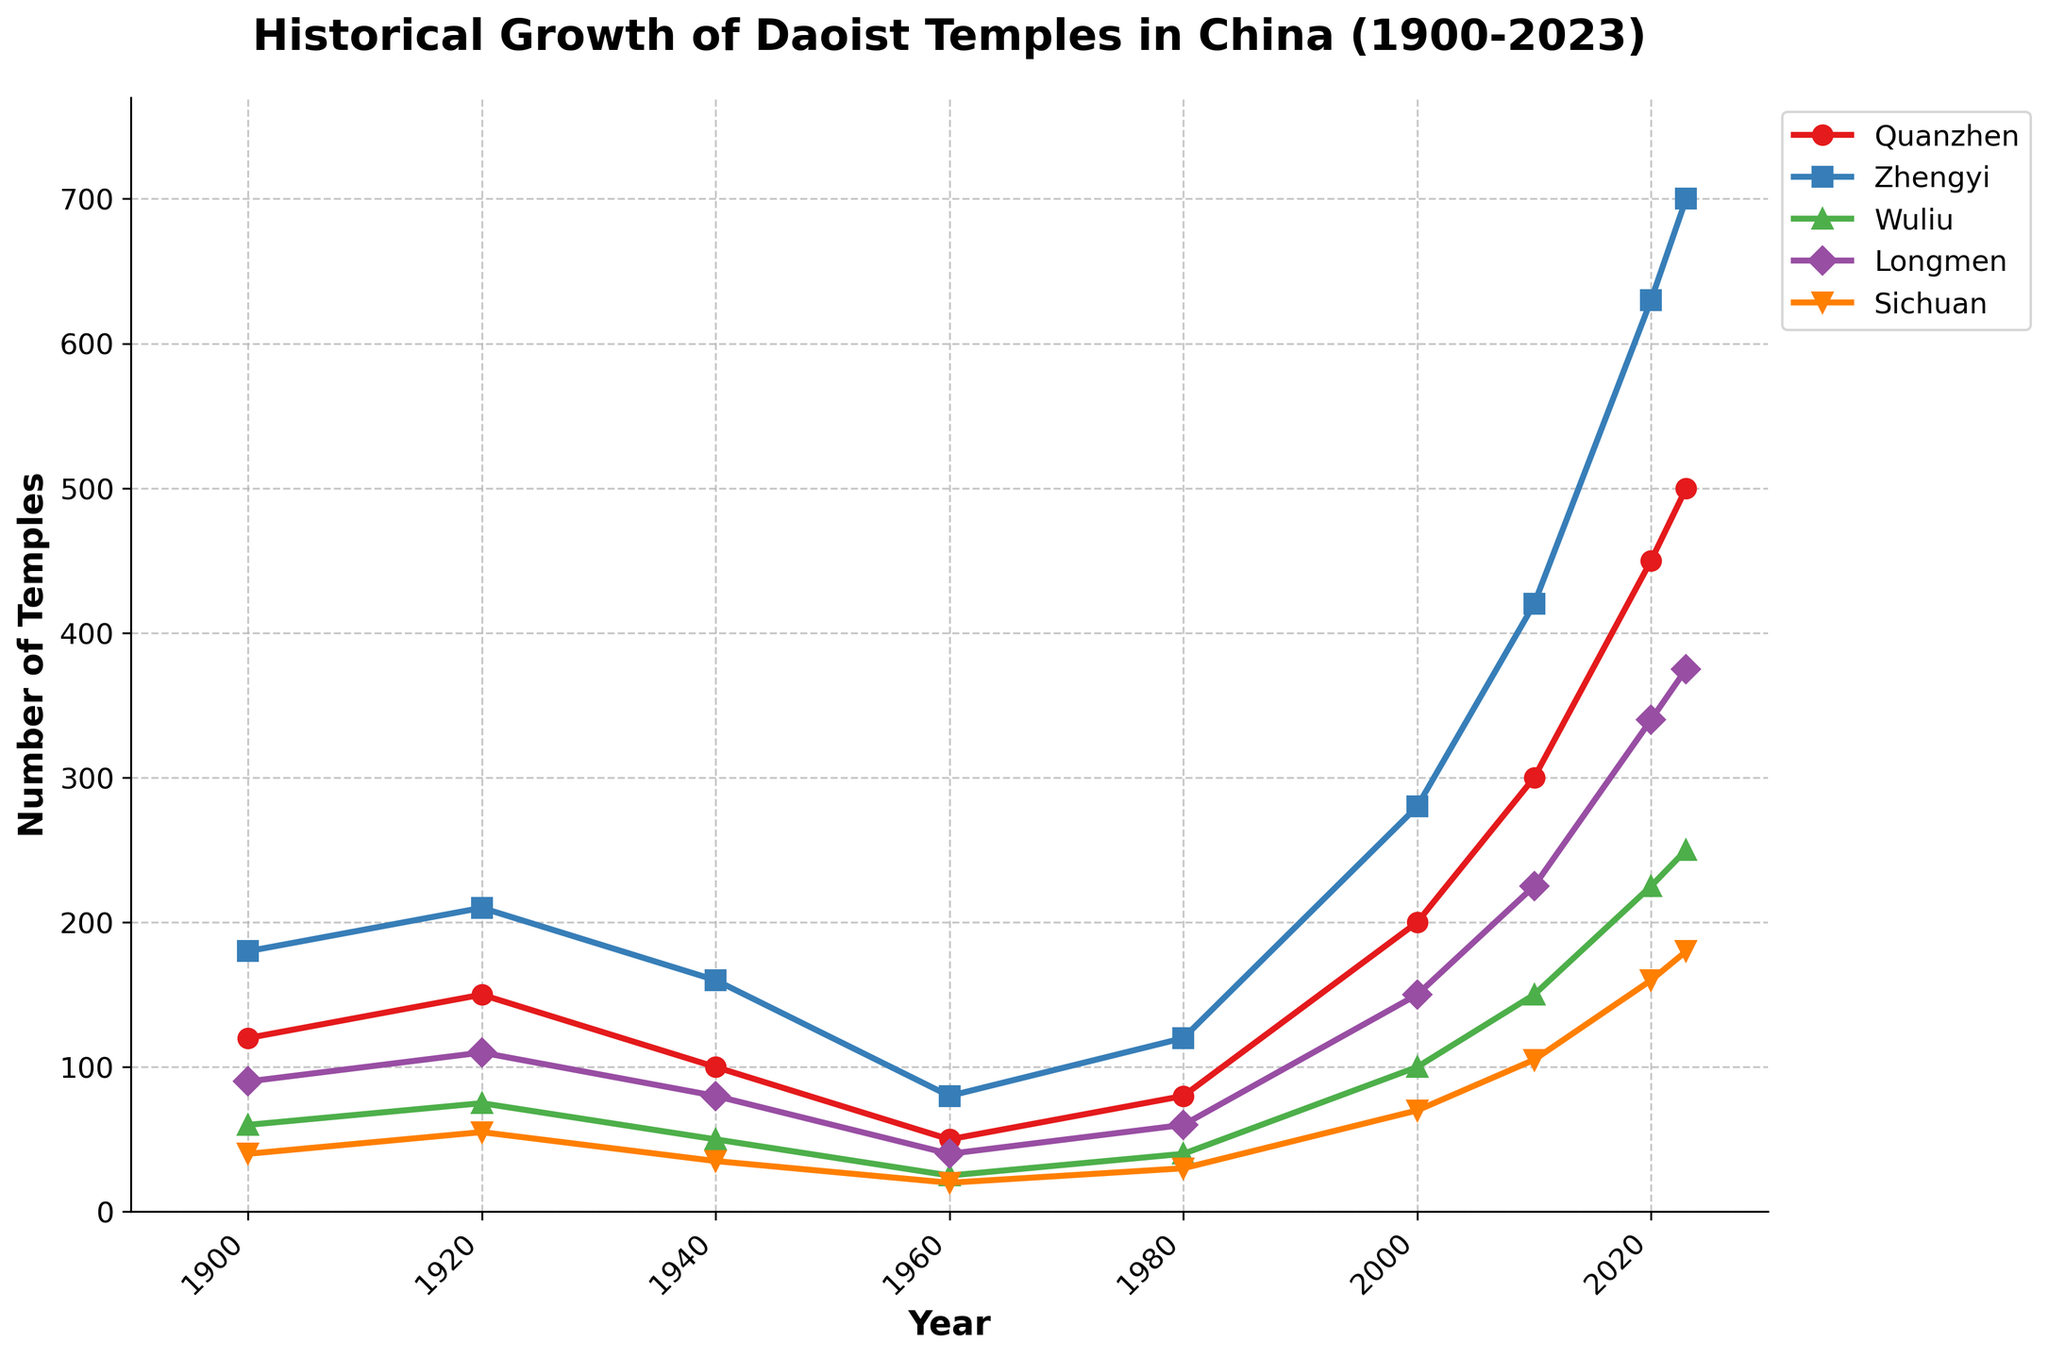What period saw a decline in the number of Wuliu temples? During 1940 and 1960, the number of Wuliu temples declined from 50 to 25. This is observed by checking the data points on the graph for these years.
Answer: 1940-1960 Which Daoist school had the highest number of temples in 2020? In 2020, the graph shows that the Zhengyi school had the highest number of temples with a count reaching 630, which is higher than the counts for Quanzhen, Wuliu, Longmen, and Sichuan schools.
Answer: Zhengyi Between which years did the Quanzhen school see the largest growth in the number of temples? Observing the graph, between 2010 and 2020, Quanzhen temples increased significantly from 300 to 450. The growth here is 150, which is the largest when compared to other time periods.
Answer: 2010-2020 How many more temples did the Longmen school have in 2023 compared to 1940? In 2023, the Longmen school had 375 temples, while in 1940 it had 80 temples. The difference is 375 - 80 = 295.
Answer: 295 What is the average number of temples for the Sichuan school over the years provided? Sum the values for the Sichuan school: 40 + 55 + 35 + 20 + 30 + 70 + 105 + 160 + 180 = 695. There are 9 data points, so the average is 695 / 9 ≈ 77.22
Answer: 77.22 Which year saw the lowest number of temples for the Zhengyi school? The graph shows the lowest point for the Zhengyi school around 1960, where the number of temples is 80.
Answer: 1960 In which periods did all schools collectively increase their number of temples? Between 1980 and 2020, all schools show an upward trend. This trend can be confirmed by observing the consistent rise for each school's line on the graph throughout these years.
Answer: 1980-2020 How many temples did the Wuliu school gain between 2000 and 2010? In 2000, Wuliu had 100 temples and in 2010, it had 150 temples. The gain is 150 - 100 = 50.
Answer: 50 Compare the growth rates of Quanzhen and Sichuan schools from 1900 to 2023. Quanzhen grew from 120 to 500, a total increase of 380. Sichuan grew from 40 to 180, an increase of 140. Quanzhen's growth of 380 is significantly higher than Sichuan's growth of 140.
Answer: Quanzhen > Sichuan Which school had the smallest increase in the number of temples from 2000 to 2010? Between 2000 and 2010, the smallest increase is seen in Wuliu school, increasing from 100 to 150, a difference of 50. All other schools had larger increases.
Answer: Wuliu 